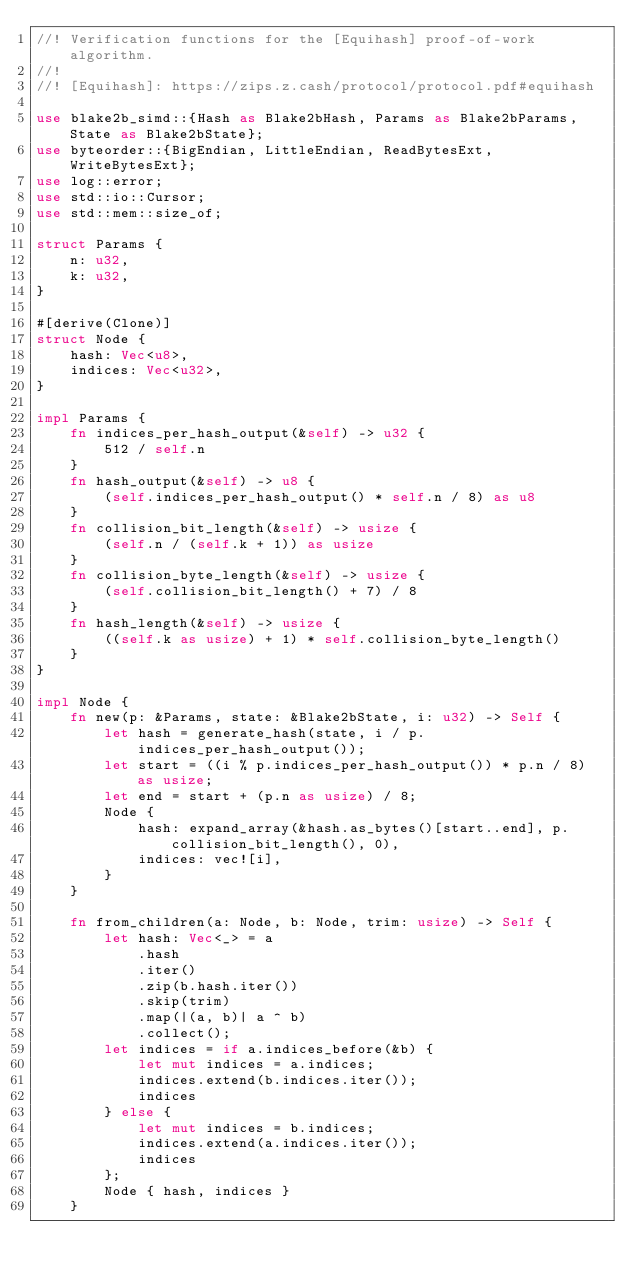<code> <loc_0><loc_0><loc_500><loc_500><_Rust_>//! Verification functions for the [Equihash] proof-of-work algorithm.
//!
//! [Equihash]: https://zips.z.cash/protocol/protocol.pdf#equihash

use blake2b_simd::{Hash as Blake2bHash, Params as Blake2bParams, State as Blake2bState};
use byteorder::{BigEndian, LittleEndian, ReadBytesExt, WriteBytesExt};
use log::error;
use std::io::Cursor;
use std::mem::size_of;

struct Params {
    n: u32,
    k: u32,
}

#[derive(Clone)]
struct Node {
    hash: Vec<u8>,
    indices: Vec<u32>,
}

impl Params {
    fn indices_per_hash_output(&self) -> u32 {
        512 / self.n
    }
    fn hash_output(&self) -> u8 {
        (self.indices_per_hash_output() * self.n / 8) as u8
    }
    fn collision_bit_length(&self) -> usize {
        (self.n / (self.k + 1)) as usize
    }
    fn collision_byte_length(&self) -> usize {
        (self.collision_bit_length() + 7) / 8
    }
    fn hash_length(&self) -> usize {
        ((self.k as usize) + 1) * self.collision_byte_length()
    }
}

impl Node {
    fn new(p: &Params, state: &Blake2bState, i: u32) -> Self {
        let hash = generate_hash(state, i / p.indices_per_hash_output());
        let start = ((i % p.indices_per_hash_output()) * p.n / 8) as usize;
        let end = start + (p.n as usize) / 8;
        Node {
            hash: expand_array(&hash.as_bytes()[start..end], p.collision_bit_length(), 0),
            indices: vec![i],
        }
    }

    fn from_children(a: Node, b: Node, trim: usize) -> Self {
        let hash: Vec<_> = a
            .hash
            .iter()
            .zip(b.hash.iter())
            .skip(trim)
            .map(|(a, b)| a ^ b)
            .collect();
        let indices = if a.indices_before(&b) {
            let mut indices = a.indices;
            indices.extend(b.indices.iter());
            indices
        } else {
            let mut indices = b.indices;
            indices.extend(a.indices.iter());
            indices
        };
        Node { hash, indices }
    }
</code> 